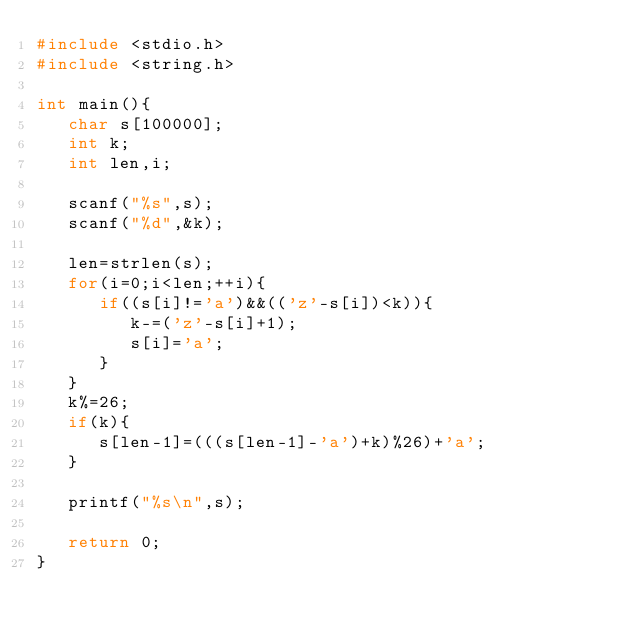Convert code to text. <code><loc_0><loc_0><loc_500><loc_500><_C++_>#include <stdio.h>
#include <string.h>
 
int main(){
   char s[100000];
   int k;
   int len,i;
 
   scanf("%s",s);
   scanf("%d",&k);
 
   len=strlen(s);
   for(i=0;i<len;++i){
      if((s[i]!='a')&&(('z'-s[i])<k)){
         k-=('z'-s[i]+1);
         s[i]='a';
      }
   }
   k%=26;
   if(k){
      s[len-1]=(((s[len-1]-'a')+k)%26)+'a';
   }
 
   printf("%s\n",s);
 
   return 0;
}
</code> 